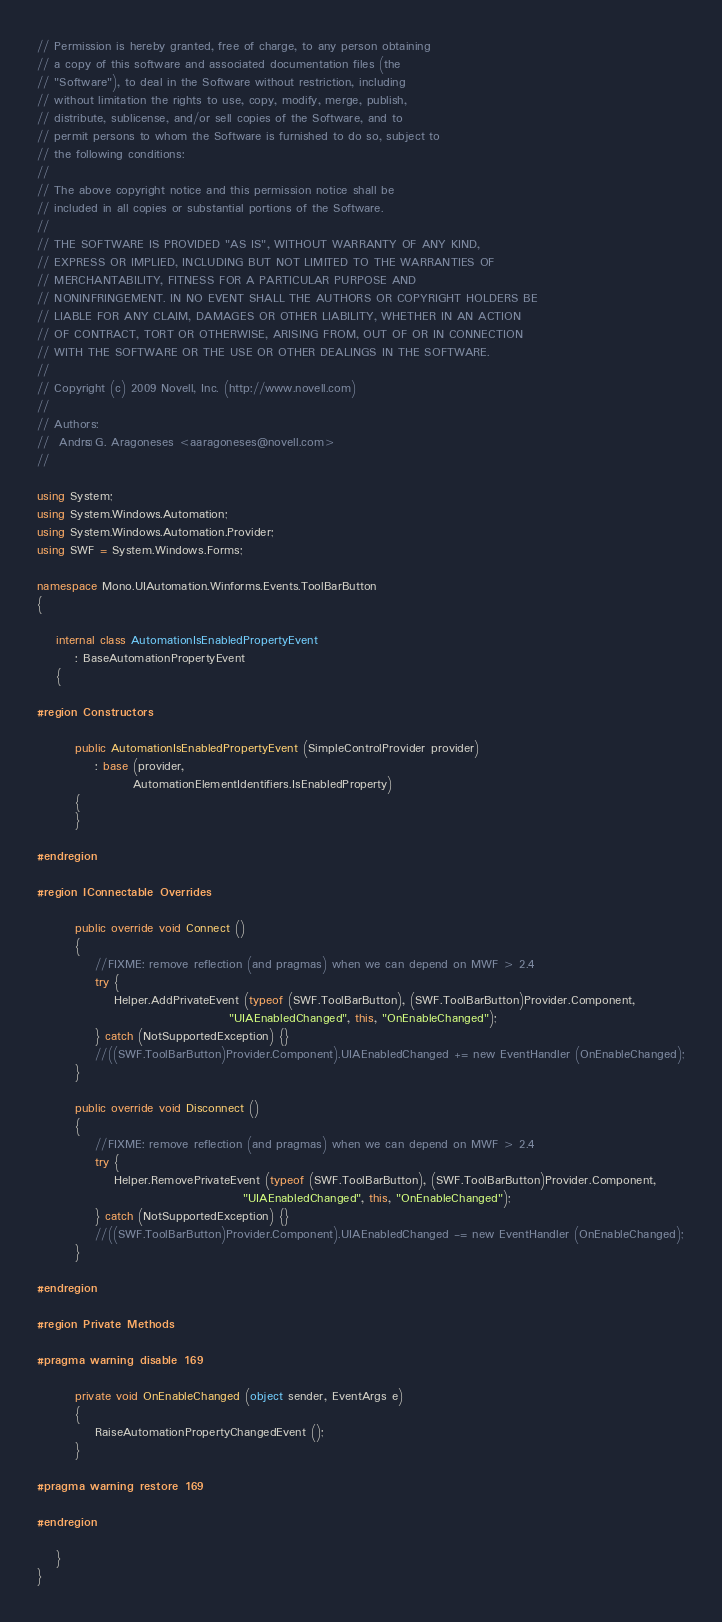Convert code to text. <code><loc_0><loc_0><loc_500><loc_500><_C#_>// Permission is hereby granted, free of charge, to any person obtaining 
// a copy of this software and associated documentation files (the 
// "Software"), to deal in the Software without restriction, including 
// without limitation the rights to use, copy, modify, merge, publish, 
// distribute, sublicense, and/or sell copies of the Software, and to 
// permit persons to whom the Software is furnished to do so, subject to 
// the following conditions: 
//  
// The above copyright notice and this permission notice shall be 
// included in all copies or substantial portions of the Software. 
//  
// THE SOFTWARE IS PROVIDED "AS IS", WITHOUT WARRANTY OF ANY KIND, 
// EXPRESS OR IMPLIED, INCLUDING BUT NOT LIMITED TO THE WARRANTIES OF 
// MERCHANTABILITY, FITNESS FOR A PARTICULAR PURPOSE AND 
// NONINFRINGEMENT. IN NO EVENT SHALL THE AUTHORS OR COPYRIGHT HOLDERS BE 
// LIABLE FOR ANY CLAIM, DAMAGES OR OTHER LIABILITY, WHETHER IN AN ACTION 
// OF CONTRACT, TORT OR OTHERWISE, ARISING FROM, OUT OF OR IN CONNECTION 
// WITH THE SOFTWARE OR THE USE OR OTHER DEALINGS IN THE SOFTWARE. 
// 
// Copyright (c) 2009 Novell, Inc. (http://www.novell.com) 
// 
// Authors: 
//	Andrés G. Aragoneses <aaragoneses@novell.com>
// 

using System;
using System.Windows.Automation;
using System.Windows.Automation.Provider;
using SWF = System.Windows.Forms;

namespace Mono.UIAutomation.Winforms.Events.ToolBarButton
{

	internal class AutomationIsEnabledPropertyEvent 
		: BaseAutomationPropertyEvent
	{
		
#region Constructors

		public AutomationIsEnabledPropertyEvent (SimpleControlProvider provider) 
			: base (provider,
			        AutomationElementIdentifiers.IsEnabledProperty)
		{
		}
		
#endregion

#region IConnectable Overrides		

		public override void Connect ()
		{
			//FIXME: remove reflection (and pragmas) when we can depend on MWF > 2.4
			try {
				Helper.AddPrivateEvent (typeof (SWF.ToolBarButton), (SWF.ToolBarButton)Provider.Component,
				                        "UIAEnabledChanged", this, "OnEnableChanged");
			} catch (NotSupportedException) {}
			//((SWF.ToolBarButton)Provider.Component).UIAEnabledChanged += new EventHandler (OnEnableChanged);
		}

		public override void Disconnect ()
		{
			//FIXME: remove reflection (and pragmas) when we can depend on MWF > 2.4
			try {
				Helper.RemovePrivateEvent (typeof (SWF.ToolBarButton), (SWF.ToolBarButton)Provider.Component,
				                           "UIAEnabledChanged", this, "OnEnableChanged");
			} catch (NotSupportedException) {}
			//((SWF.ToolBarButton)Provider.Component).UIAEnabledChanged -= new EventHandler (OnEnableChanged);
		}

#endregion
		
#region Private Methods

#pragma warning disable 169
		
		private void OnEnableChanged (object sender, EventArgs e)
		{
			RaiseAutomationPropertyChangedEvent ();
		}
		
#pragma warning restore 169
		
#endregion

	}
}
</code> 